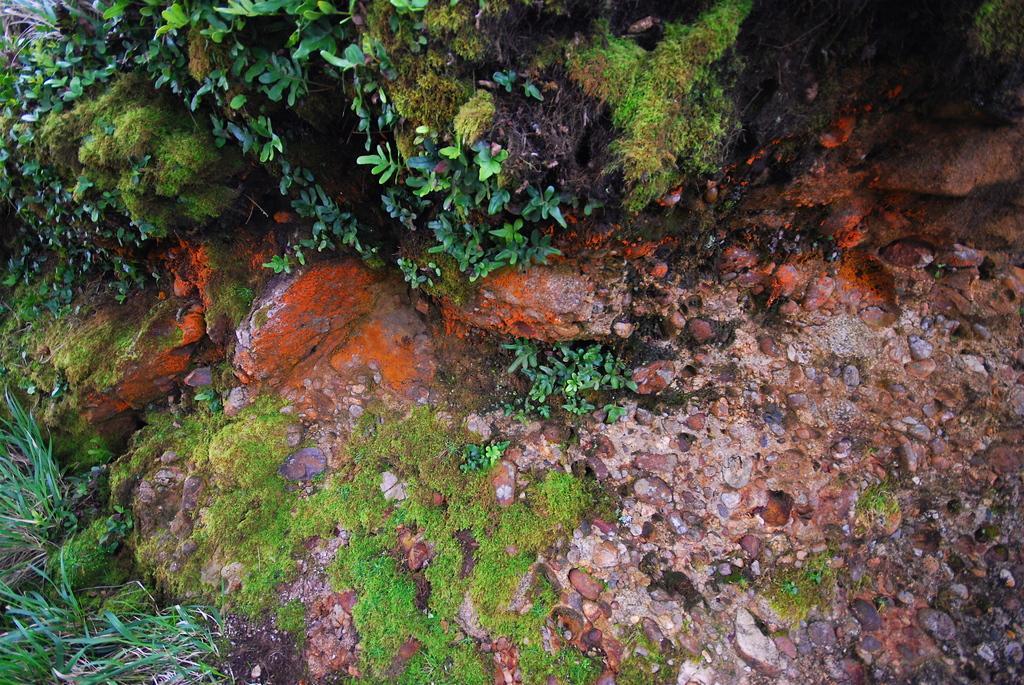How would you summarize this image in a sentence or two? In this picture we can see plants, grass, stones and rocks. 